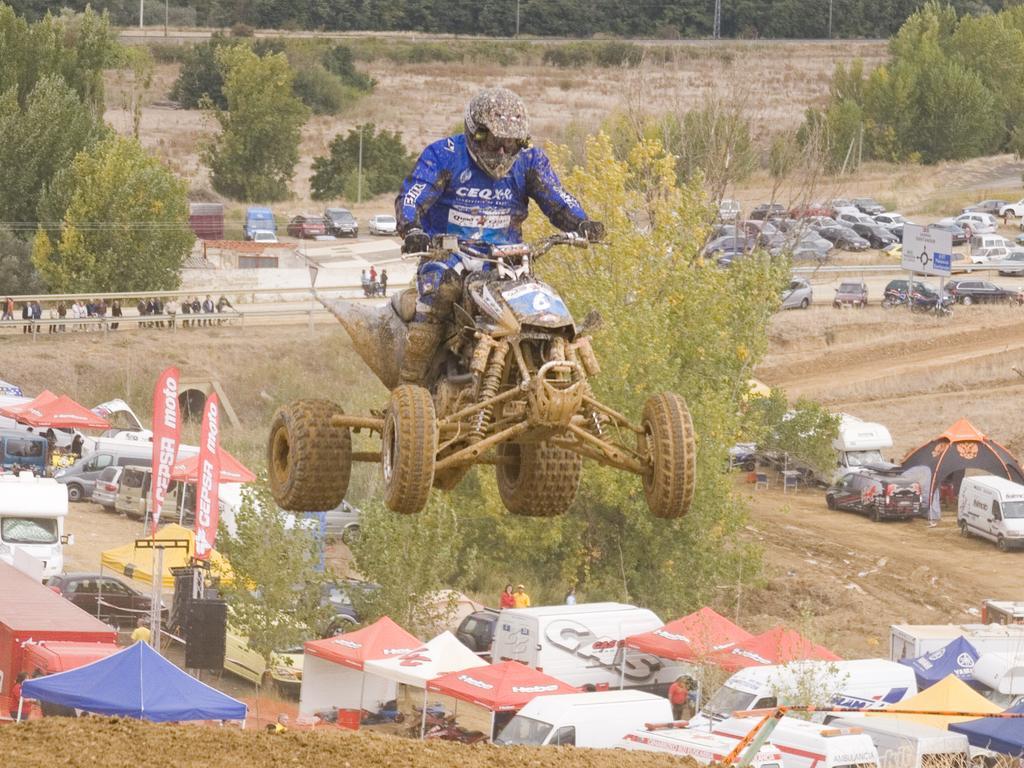Please provide a concise description of this image. In this picture I can see there is a man riding a quad bike and he is wearing a blue uniform and a helmet. There is mud all over him and the bike, the floor is wet and there is mud and there are few tents, many vehicles parked, there are few people standing on to left behind the fence and there are trees and the sky is clear. 